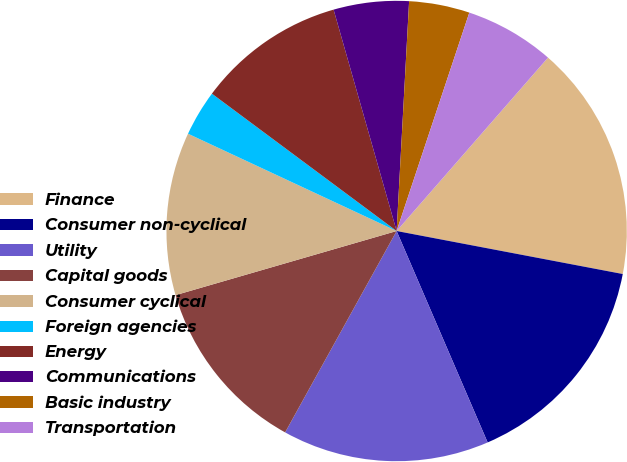<chart> <loc_0><loc_0><loc_500><loc_500><pie_chart><fcel>Finance<fcel>Consumer non-cyclical<fcel>Utility<fcel>Capital goods<fcel>Consumer cyclical<fcel>Foreign agencies<fcel>Energy<fcel>Communications<fcel>Basic industry<fcel>Transportation<nl><fcel>16.57%<fcel>15.54%<fcel>14.52%<fcel>12.46%<fcel>11.44%<fcel>3.23%<fcel>10.41%<fcel>5.28%<fcel>4.25%<fcel>6.31%<nl></chart> 